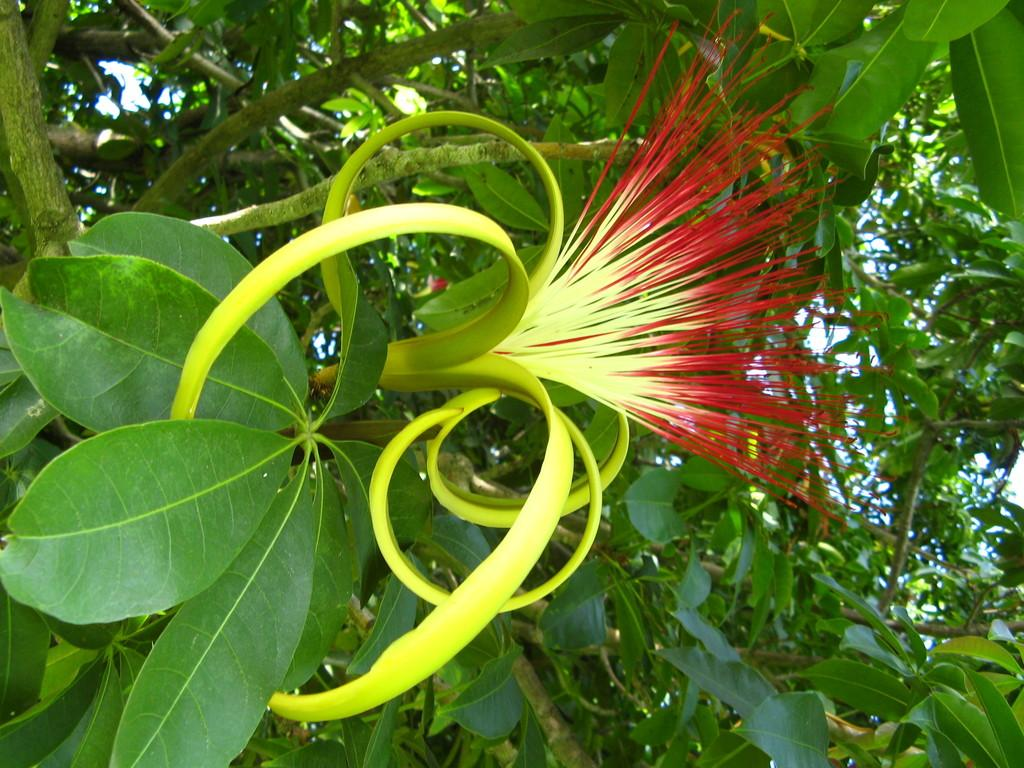What type of plant can be seen in the image? There is a flower in the image. What other plants are visible in the image? There are trees in the image. What type of substance is being used by the snakes in the image? There are no snakes present in the image, so it is not possible to determine what substance they might be using. 